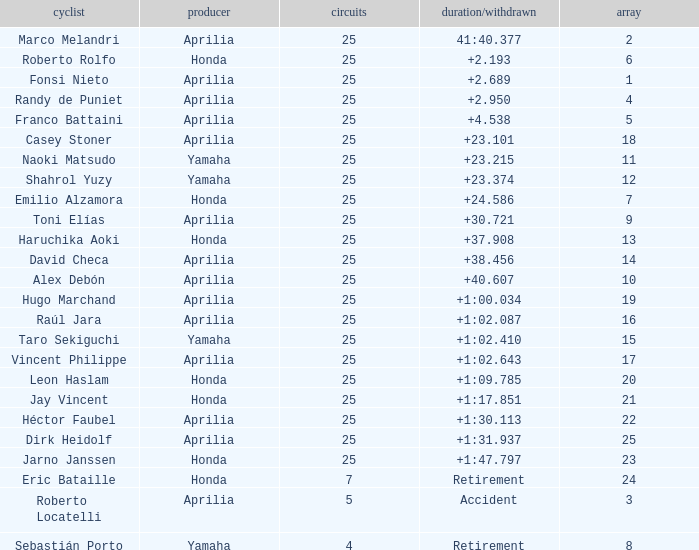Which Manufacturer has a Time/Retired of accident? Aprilia. Parse the table in full. {'header': ['cyclist', 'producer', 'circuits', 'duration/withdrawn', 'array'], 'rows': [['Marco Melandri', 'Aprilia', '25', '41:40.377', '2'], ['Roberto Rolfo', 'Honda', '25', '+2.193', '6'], ['Fonsi Nieto', 'Aprilia', '25', '+2.689', '1'], ['Randy de Puniet', 'Aprilia', '25', '+2.950', '4'], ['Franco Battaini', 'Aprilia', '25', '+4.538', '5'], ['Casey Stoner', 'Aprilia', '25', '+23.101', '18'], ['Naoki Matsudo', 'Yamaha', '25', '+23.215', '11'], ['Shahrol Yuzy', 'Yamaha', '25', '+23.374', '12'], ['Emilio Alzamora', 'Honda', '25', '+24.586', '7'], ['Toni Elías', 'Aprilia', '25', '+30.721', '9'], ['Haruchika Aoki', 'Honda', '25', '+37.908', '13'], ['David Checa', 'Aprilia', '25', '+38.456', '14'], ['Alex Debón', 'Aprilia', '25', '+40.607', '10'], ['Hugo Marchand', 'Aprilia', '25', '+1:00.034', '19'], ['Raúl Jara', 'Aprilia', '25', '+1:02.087', '16'], ['Taro Sekiguchi', 'Yamaha', '25', '+1:02.410', '15'], ['Vincent Philippe', 'Aprilia', '25', '+1:02.643', '17'], ['Leon Haslam', 'Honda', '25', '+1:09.785', '20'], ['Jay Vincent', 'Honda', '25', '+1:17.851', '21'], ['Héctor Faubel', 'Aprilia', '25', '+1:30.113', '22'], ['Dirk Heidolf', 'Aprilia', '25', '+1:31.937', '25'], ['Jarno Janssen', 'Honda', '25', '+1:47.797', '23'], ['Eric Bataille', 'Honda', '7', 'Retirement', '24'], ['Roberto Locatelli', 'Aprilia', '5', 'Accident', '3'], ['Sebastián Porto', 'Yamaha', '4', 'Retirement', '8']]} 